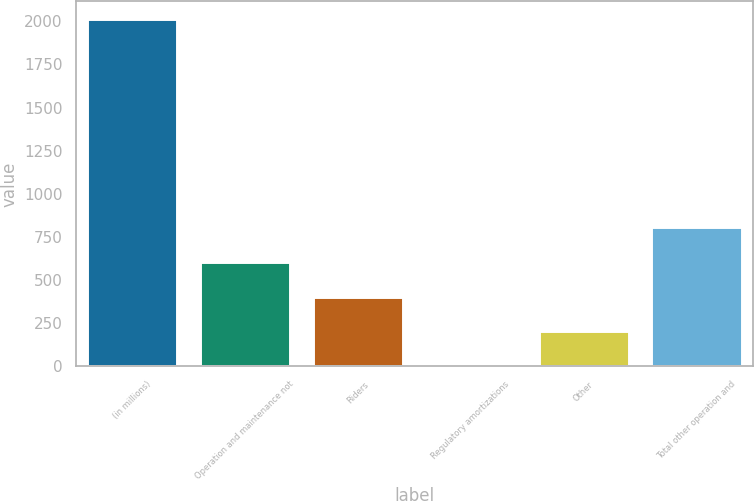<chart> <loc_0><loc_0><loc_500><loc_500><bar_chart><fcel>(in millions)<fcel>Operation and maintenance not<fcel>Riders<fcel>Regulatory amortizations<fcel>Other<fcel>Total other operation and<nl><fcel>2015<fcel>605.41<fcel>404.04<fcel>1.3<fcel>202.67<fcel>806.78<nl></chart> 